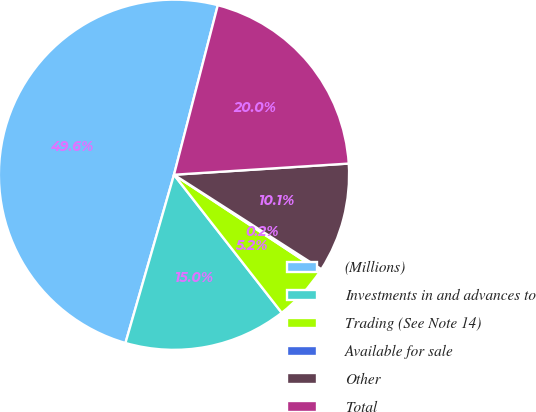Convert chart to OTSL. <chart><loc_0><loc_0><loc_500><loc_500><pie_chart><fcel>(Millions)<fcel>Investments in and advances to<fcel>Trading (See Note 14)<fcel>Available for sale<fcel>Other<fcel>Total<nl><fcel>49.56%<fcel>15.02%<fcel>5.16%<fcel>0.22%<fcel>10.09%<fcel>19.96%<nl></chart> 